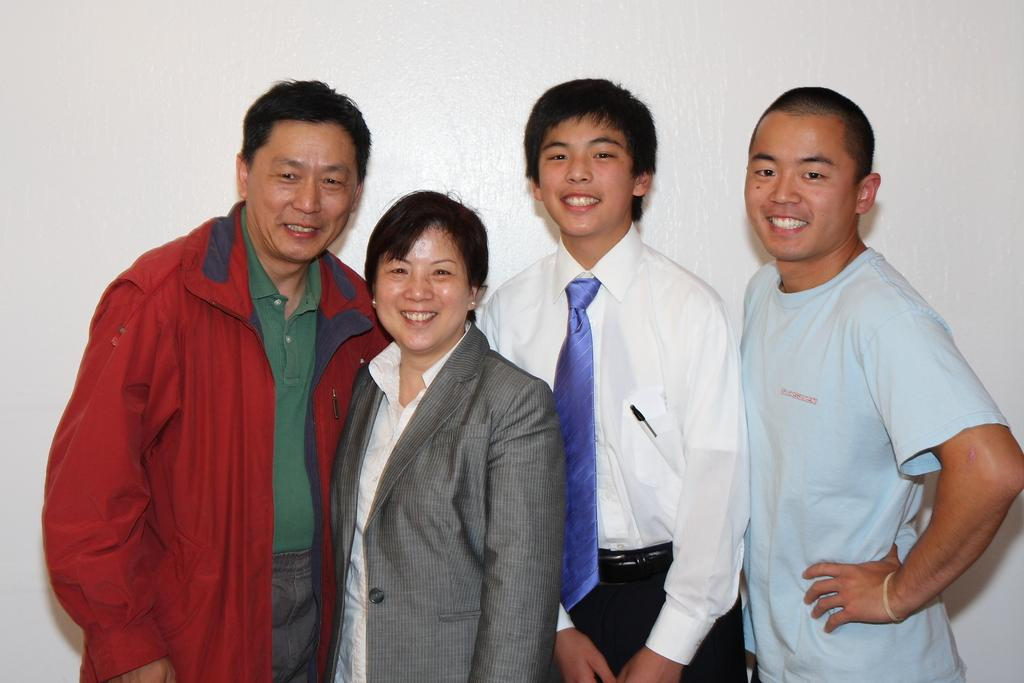How many people are in the image? There are four people in the image: three men and one woman. What are the people in the image doing? The people are standing and smiling. What can be seen in the background of the image? There is a wall in the background of the image. What type of industry can be seen in the image? There is no industry present in the image; it features people standing and smiling with a wall in the background. How many birds are visible in the image? There are no birds visible in the image. 